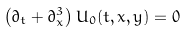<formula> <loc_0><loc_0><loc_500><loc_500>\left ( \partial _ { t } + \partial ^ { 3 } _ { x } \right ) U _ { 0 } ( t , x , y ) = 0</formula> 